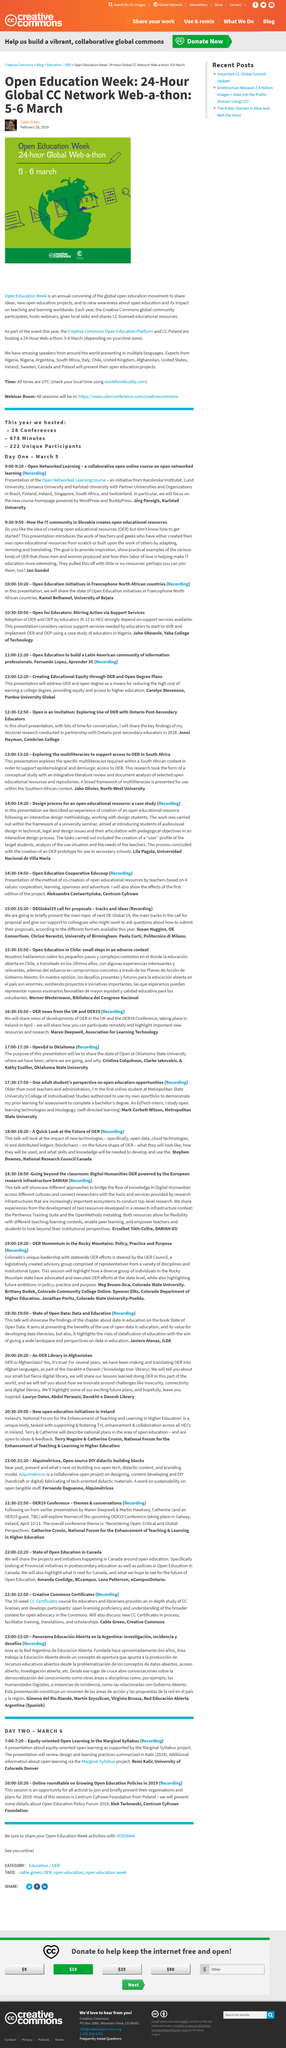Indicate a few pertinent items in this graphic. According to the image, the dates of the Web-a-thon are 5-6 March. The title CC in Creative Commons stands for. The Creative Commons Open Education Platform in Poland is co-hosting a Web-a-thon. 